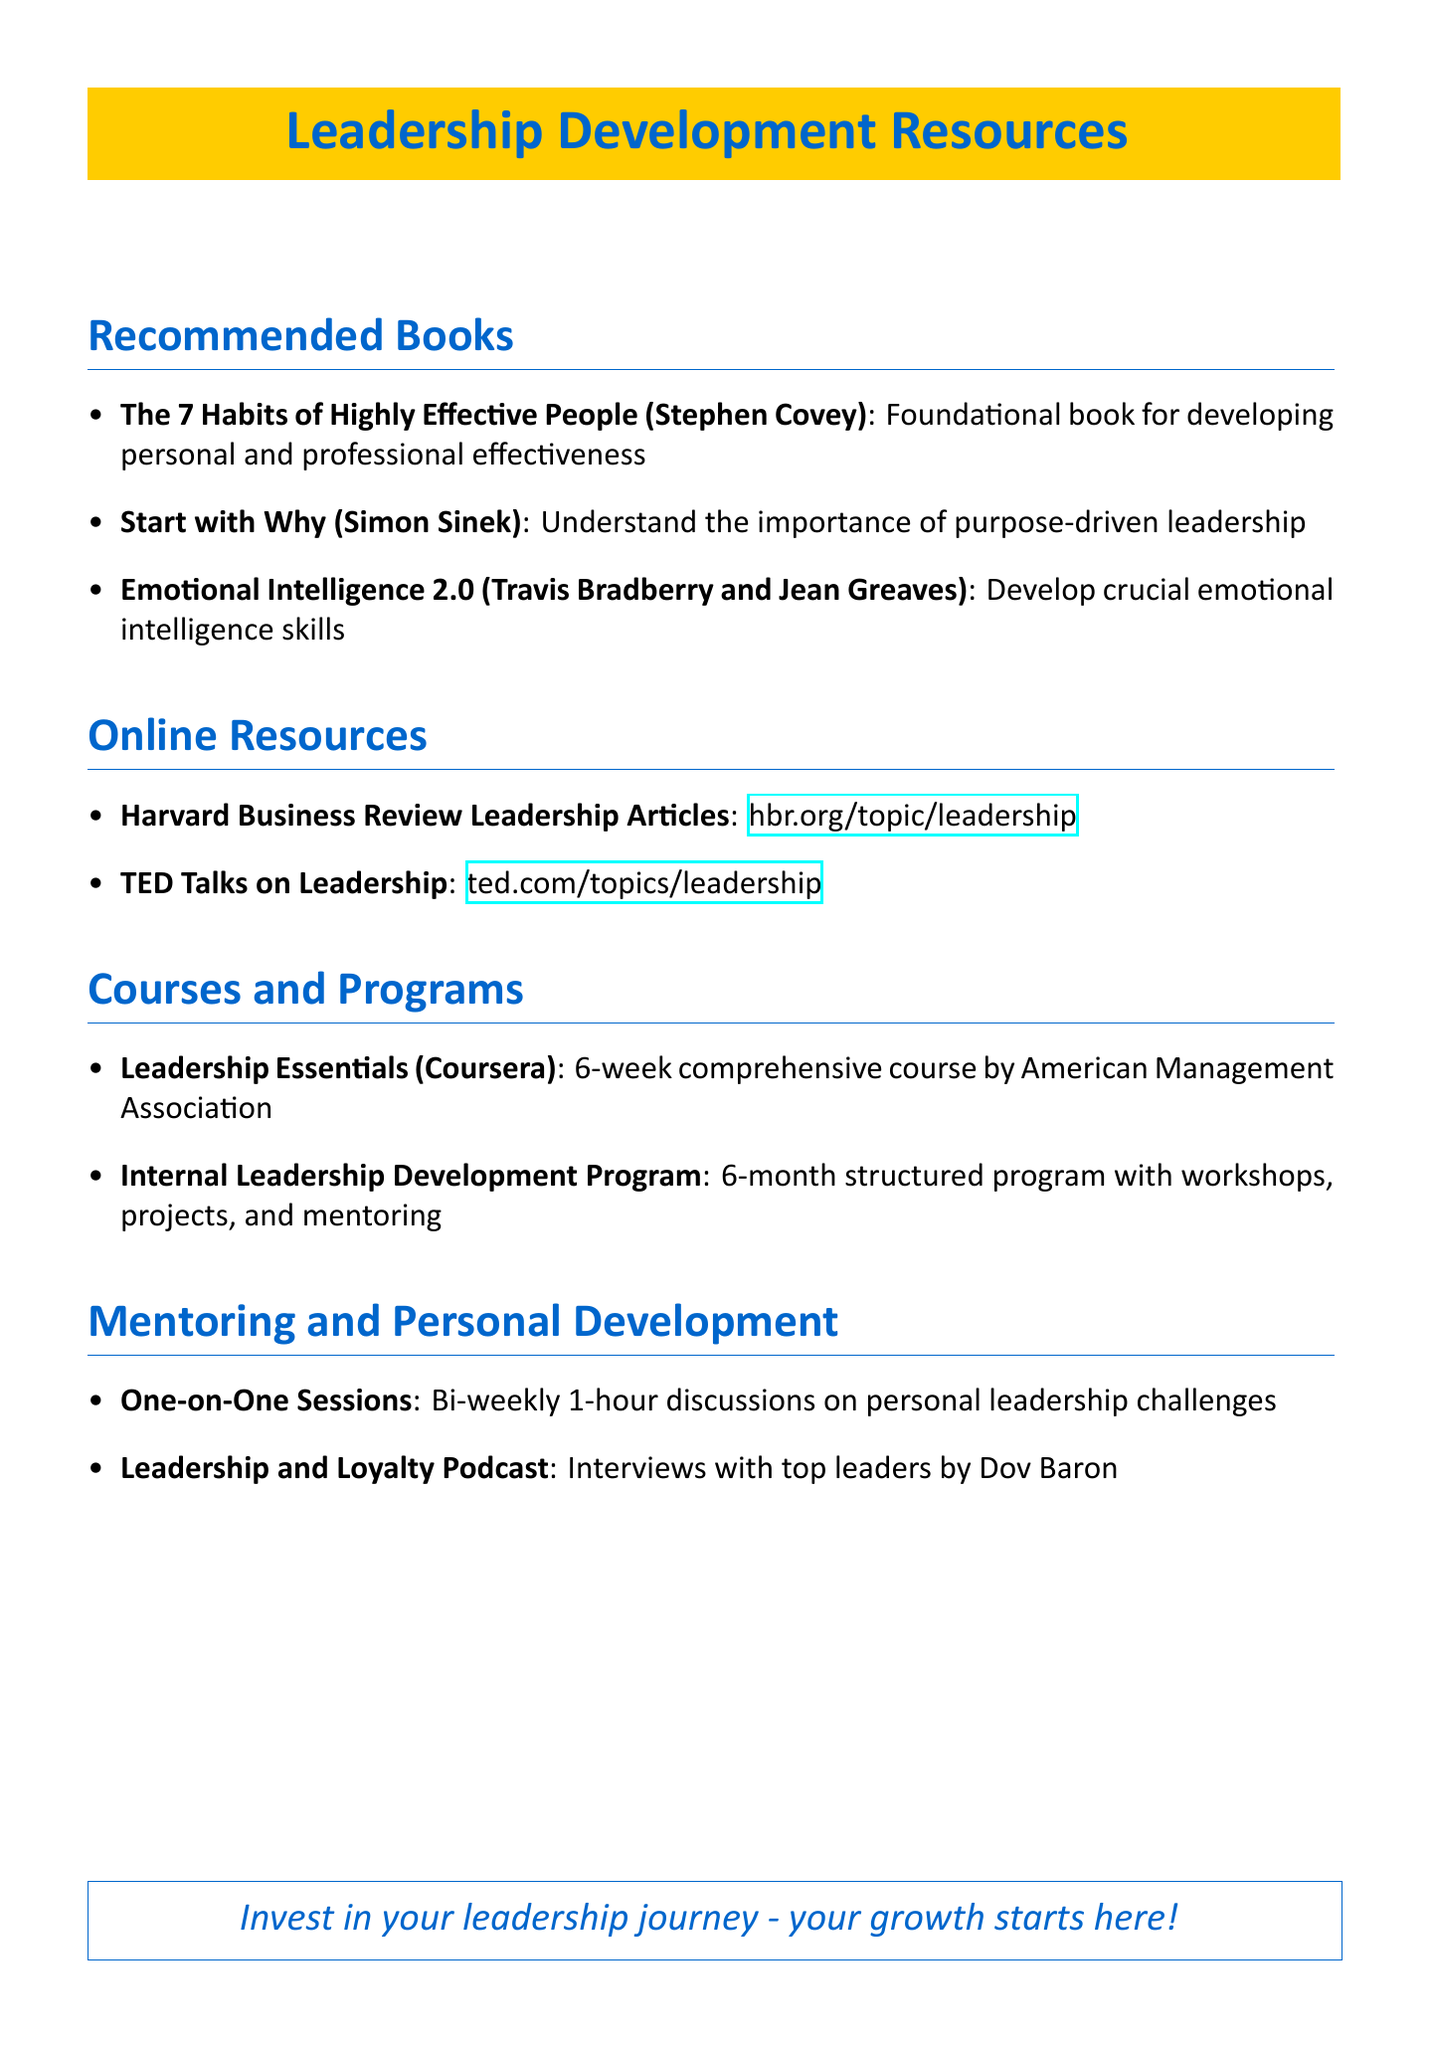What is the title of Stephen Covey's book? The title of the book by Stephen Covey mentioned in the document is "The 7 Habits of Highly Effective People."
Answer: The 7 Habits of Highly Effective People How many weeks is the "Leadership Essentials" course? The duration of the "Leadership Essentials" course is specified as 6 weeks in the document.
Answer: 6 weeks What is the main focus of "Start with Why"? The book "Start with Why" emphasizes understanding the importance of purpose-driven leadership according to the document.
Answer: Purpose-driven leadership How often are the mentoring sessions held? The document states that the mentoring sessions are held bi-weekly.
Answer: Bi-weekly What type of content does "Harvard Business Review Leadership Articles" offer? The document describes "Harvard Business Review Leadership Articles" as offering curated articles from industry experts on various leadership topics.
Answer: Curated articles How long is the Internal Leadership Development Program? The duration of the Internal Leadership Development Program is outlined in the document as 6 months.
Answer: 6 months Who hosts the "Leadership and Loyalty" podcast? The document specifies that "Leadership and Loyalty" podcast is hosted by Dov Baron.
Answer: Dov Baron What is the format of the recommended online resources? The document categorizes the recommended online resources as articles and talks available online.
Answer: Articles and talks What is one key aspect of the Emotional Intelligence 2.0 book? The document highlights that "Emotional Intelligence 2.0" is essential for developing emotional intelligence, which is a crucial skill for emerging leaders.
Answer: Emotional intelligence skills 